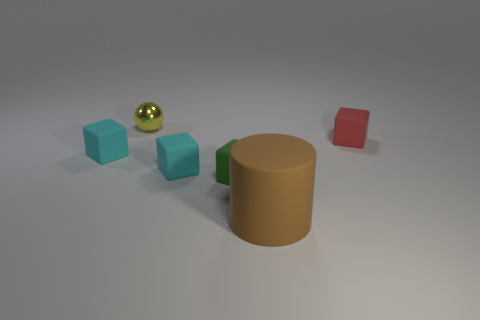What shape is the small thing behind the red cube?
Your response must be concise. Sphere. The big rubber object is what color?
Offer a terse response. Brown. Is the size of the shiny thing the same as the cyan block on the right side of the small yellow sphere?
Your answer should be very brief. Yes. How many metal objects are either tiny yellow balls or blocks?
Provide a succinct answer. 1. Is there anything else that has the same material as the small red thing?
Offer a very short reply. Yes. What shape is the small green rubber thing?
Provide a succinct answer. Cube. There is a brown object to the right of the thing behind the matte object to the right of the big matte cylinder; how big is it?
Make the answer very short. Large. How many other objects are the same shape as the small green matte object?
Ensure brevity in your answer.  3. Do the object behind the red thing and the object in front of the green rubber thing have the same shape?
Ensure brevity in your answer.  No. What number of cubes are either tiny cyan matte objects or brown matte objects?
Keep it short and to the point. 2. 